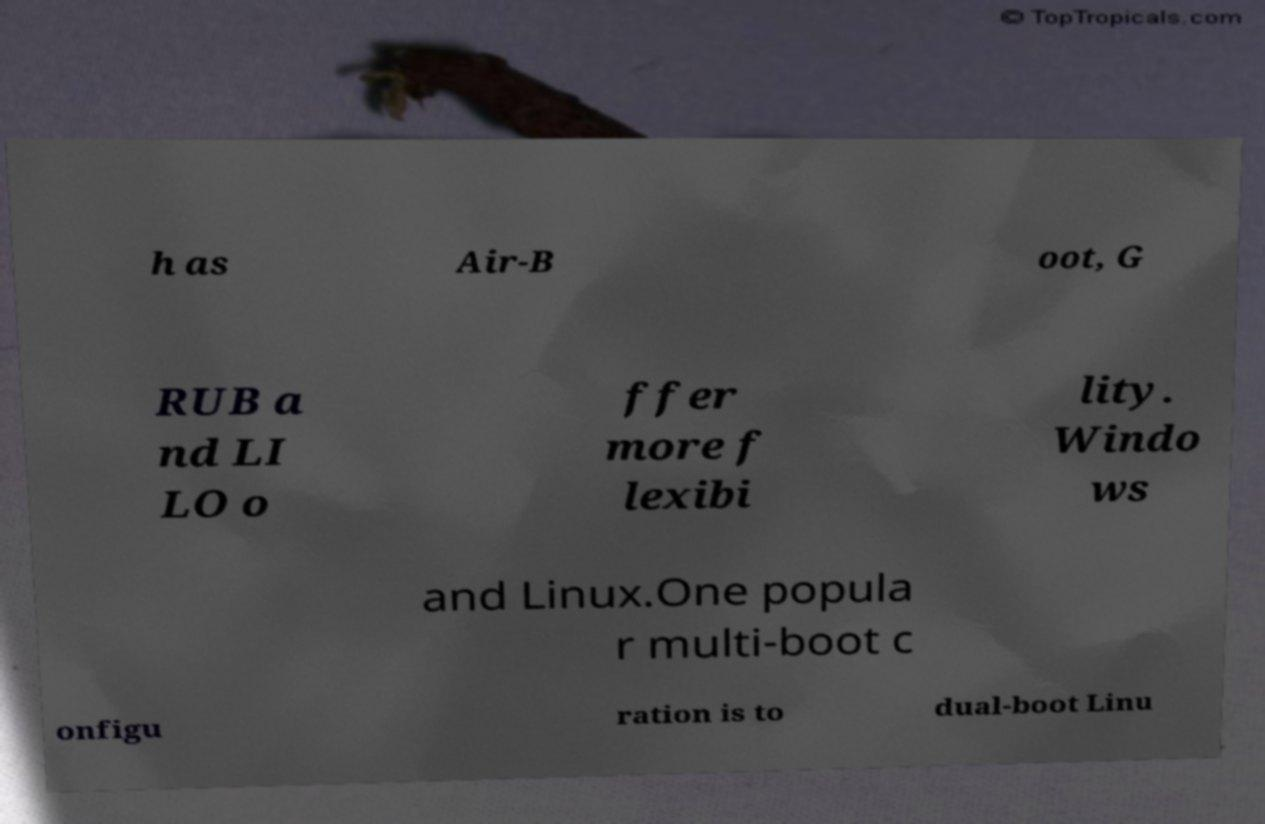Please identify and transcribe the text found in this image. h as Air-B oot, G RUB a nd LI LO o ffer more f lexibi lity. Windo ws and Linux.One popula r multi-boot c onfigu ration is to dual-boot Linu 